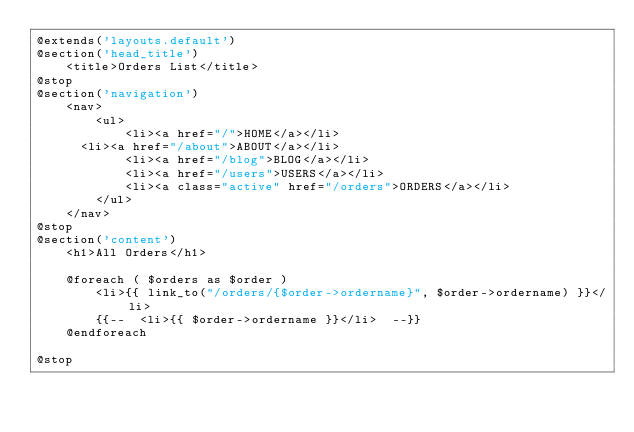Convert code to text. <code><loc_0><loc_0><loc_500><loc_500><_PHP_>@extends('layouts.default')
@section('head_title')
    <title>Orders List</title>
@stop
@section('navigation')
    <nav>
        <ul>
            <li><a href="/">HOME</a></li>
			<li><a href="/about">ABOUT</a></li>
            <li><a href="/blog">BLOG</a></li>
            <li><a href="/users">USERS</a></li>
            <li><a class="active" href="/orders">ORDERS</a></li>
        </ul>
    </nav>
@stop
@section('content')
    <h1>All Orders</h1>

    @foreach ( $orders as $order )
        <li>{{ link_to("/orders/{$order->ordername}", $order->ordername) }}</li>
        {{--  <li>{{ $order->ordername }}</li>  --}}
    @endforeach

@stop</code> 